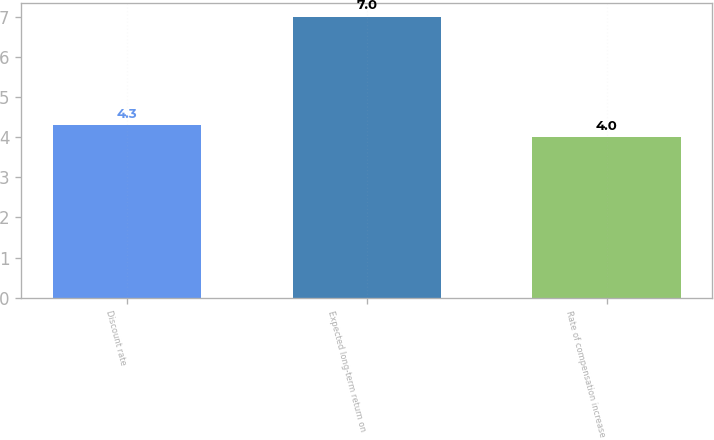Convert chart. <chart><loc_0><loc_0><loc_500><loc_500><bar_chart><fcel>Discount rate<fcel>Expected long-term return on<fcel>Rate of compensation increase<nl><fcel>4.3<fcel>7<fcel>4<nl></chart> 